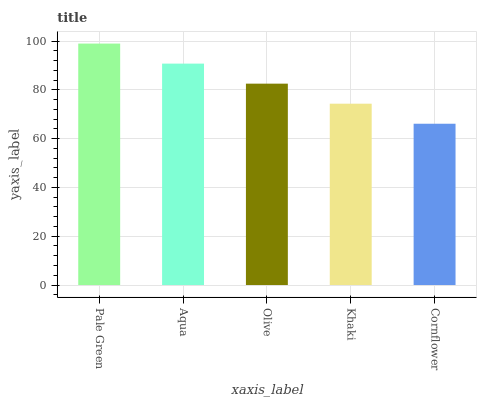Is Cornflower the minimum?
Answer yes or no. Yes. Is Pale Green the maximum?
Answer yes or no. Yes. Is Aqua the minimum?
Answer yes or no. No. Is Aqua the maximum?
Answer yes or no. No. Is Pale Green greater than Aqua?
Answer yes or no. Yes. Is Aqua less than Pale Green?
Answer yes or no. Yes. Is Aqua greater than Pale Green?
Answer yes or no. No. Is Pale Green less than Aqua?
Answer yes or no. No. Is Olive the high median?
Answer yes or no. Yes. Is Olive the low median?
Answer yes or no. Yes. Is Cornflower the high median?
Answer yes or no. No. Is Khaki the low median?
Answer yes or no. No. 